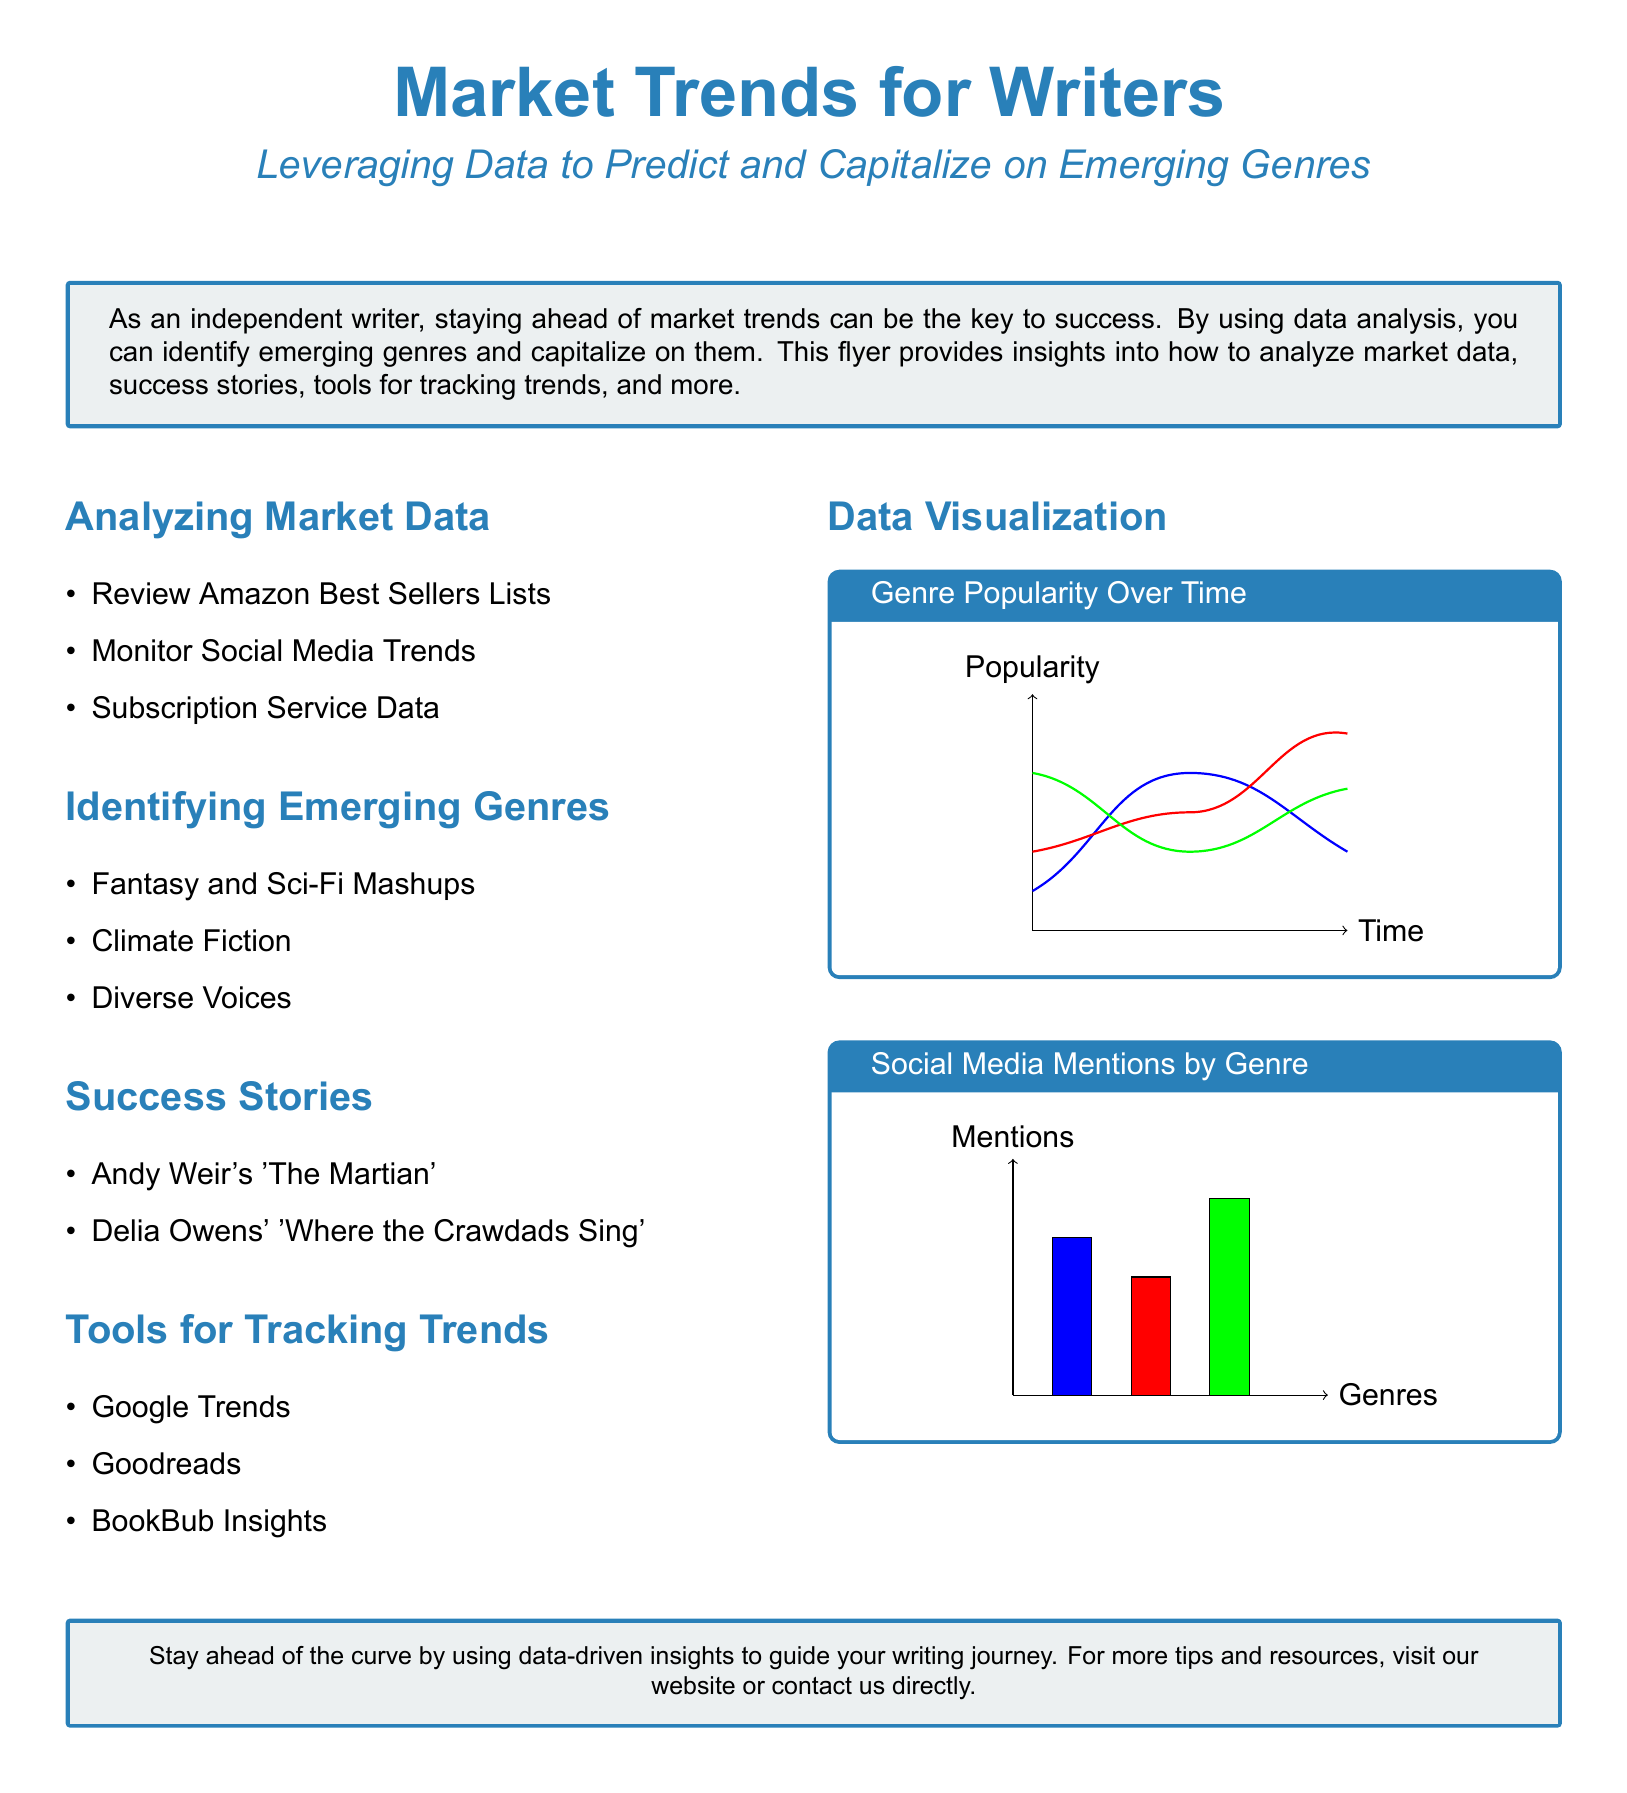What are three methods to analyze market data? The document lists methods such as reviewing Amazon Best Sellers Lists, monitoring social media trends, and subscription service data.
Answer: Amazon Best Sellers Lists, social media trends, subscription service data Which genres are identified as emerging? The document states that emerging genres include Fantasy and Sci-Fi Mashups, Climate Fiction, and Diverse Voices.
Answer: Fantasy and Sci-Fi Mashups, Climate Fiction, Diverse Voices What is one success story mentioned in the flyer? The flyer mentions Andy Weir's 'The Martian' as a success story.
Answer: Andy Weir's 'The Martian' Which tool is suggested for tracking trends? The document suggests using Google Trends as one of the tools for tracking trends.
Answer: Google Trends What does the genre popularity graph display? The genre popularity graph visually represents the popularity of various genres over time.
Answer: Popularity over time How many sections are there in the document? The document contains a total of four sections: Analyzing Market Data, Identifying Emerging Genres, Success Stories, and Tools for Tracking Trends.
Answer: Four What is the primary color used for headings? The primary color used for headings in the flyer is defined as heading color, which is RGB 41, 128, 185.
Answer: RGB 41, 128, 185 What do the social media mentions in the flyer illustrate? The social media mentions display the frequency of mentions categorized by genre.
Answer: Frequency of mentions by genre 